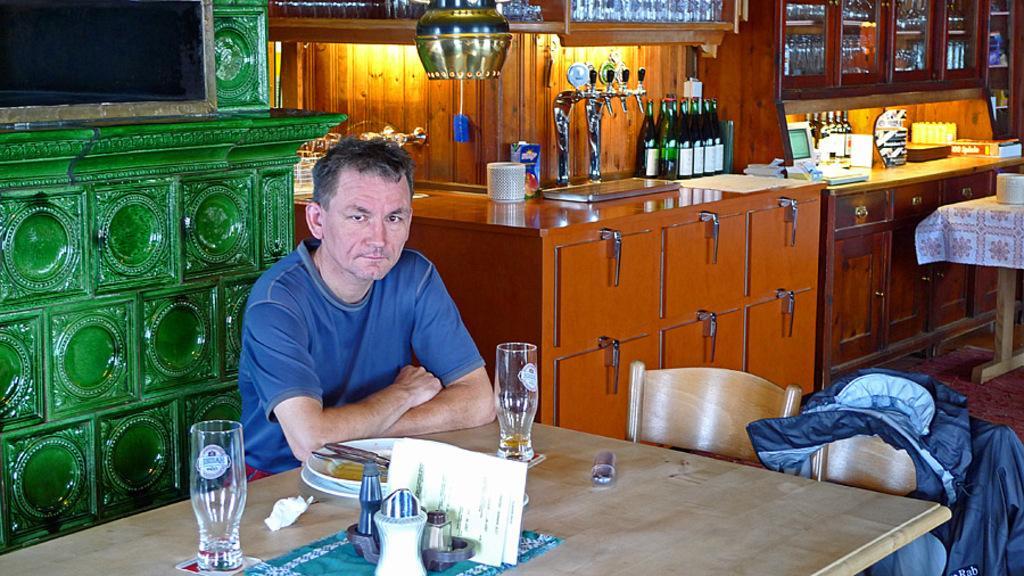Please provide a concise description of this image. In this picture we can see glasses, plates, papers on the table, in front of the table a man is seated on the chair in the background we can see couple of bottles, machine and couple of lights. 